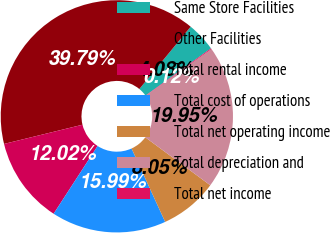Convert chart. <chart><loc_0><loc_0><loc_500><loc_500><pie_chart><fcel>Same Store Facilities<fcel>Other Facilities<fcel>Total rental income<fcel>Total cost of operations<fcel>Total net operating income<fcel>Total depreciation and<fcel>Total net income<nl><fcel>4.08%<fcel>39.79%<fcel>12.02%<fcel>15.99%<fcel>8.05%<fcel>19.95%<fcel>0.12%<nl></chart> 